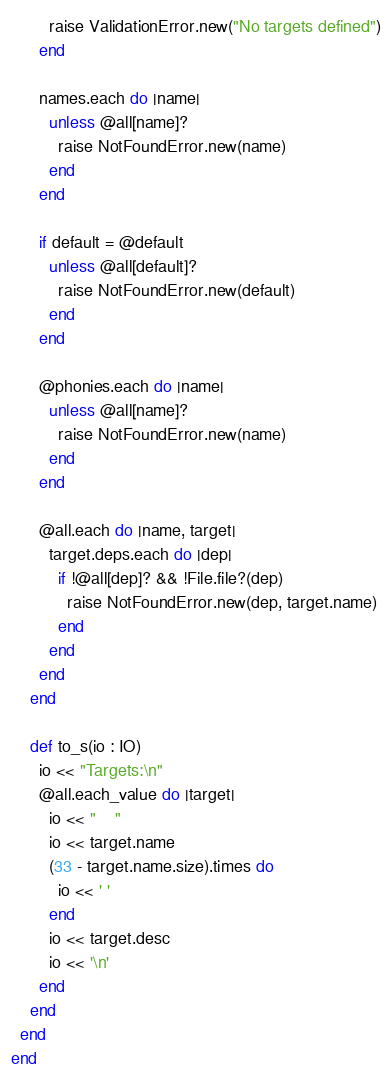Convert code to text. <code><loc_0><loc_0><loc_500><loc_500><_Crystal_>        raise ValidationError.new("No targets defined")
      end

      names.each do |name|
        unless @all[name]?
          raise NotFoundError.new(name)
        end
      end

      if default = @default
        unless @all[default]?
          raise NotFoundError.new(default)
        end
      end

      @phonies.each do |name|
        unless @all[name]?
          raise NotFoundError.new(name)
        end
      end

      @all.each do |name, target|
        target.deps.each do |dep|
          if !@all[dep]? && !File.file?(dep)
            raise NotFoundError.new(dep, target.name)
          end
        end
      end
    end

    def to_s(io : IO)
      io << "Targets:\n"
      @all.each_value do |target|
        io << "    "
        io << target.name
        (33 - target.name.size).times do
          io << ' '
        end
        io << target.desc
        io << '\n'
      end
    end
  end
end
</code> 